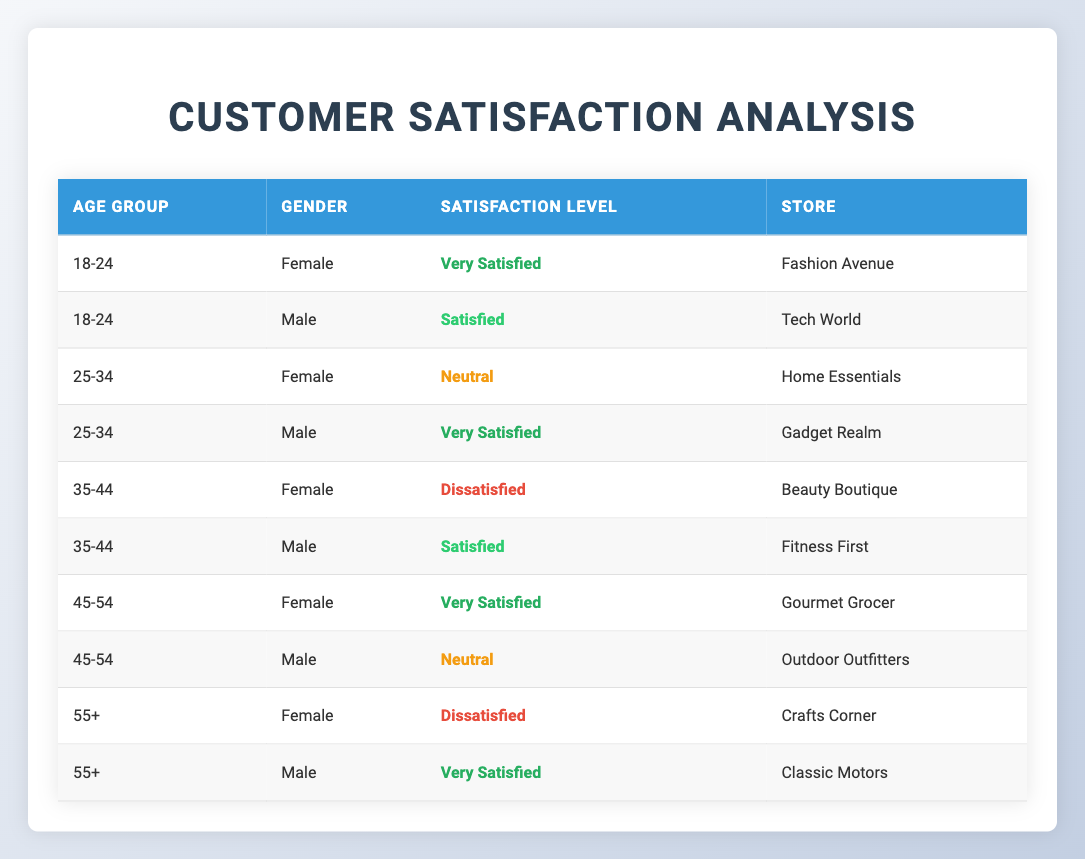What is the satisfaction level of males in the 25-34 age group? From the table, under the 25-34 age group, there is one male entry, which states the satisfaction level as "Very Satisfied."
Answer: Very Satisfied How many females reported being dissatisfied across all age groups? In the table, there are two females who reported being dissatisfied: one from the 35-44 age group and one from the 55+ age group. Thus, the total count is 2.
Answer: 2 Is there any age group where all customers are satisfied or very satisfied? By examining the table, no age group has only satisfied or very satisfied individuals; each age group has a mix of satisfaction levels.
Answer: No What is the overall satisfaction level for customers aged 18-24? For the age group 18-24, the satisfaction levels are "Very Satisfied" for females and "Satisfied" for males. Since we have different levels, we observe a mix of satisfaction.
Answer: Mixed How many males are "Very Satisfied" compared to females in the entire dataset? In the table, there are three males who are "Very Satisfied" (1 in 18-24, 1 in 25-34, and 1 in 55+), while there are two females who are "Very Satisfied" (1 in 18-24 and 1 in 45-54). The difference shows there are more males than females.
Answer: Males: 3, Females: 2 Which age group showed the highest level of dissatisfaction for females? The table shows that the highest level of dissatisfaction for females is in the 35-44 age group with the entry "Dissatisfied" being mentioned.
Answer: 35-44 What is the average satisfaction level among all age groups? There are multiple levels of satisfaction represented in the data: "Very Satisfied," "Satisfied," "Neutral," and "Dissatisfied." Calculating an average satisfaction level by assigning values (for instance, Very Satisfied as 4, Satisfied as 3, Neutral as 2, and Dissatisfied as 1) leads to: 
(4 + 3 + 2 + 1) / 4 = 2.5, indicating an overall low satisfaction.
Answer: 2.5 Does the data suggest that gender influences satisfaction levels? By analyzing the table, we see that males and females have different satisfaction levels within the same age groups, suggesting gender may play a role in satisfaction levels. However, further investigation would be needed to confirm any strong influence or generalized trends.
Answer: Yes What store has the most satisfied male customer in the dataset? The data shows the male with the highest satisfaction level is from the 55+ age group, who is "Very Satisfied" shopping at "Classic Motors." Therefore, this store has the most satisfied male customer.
Answer: Classic Motors 